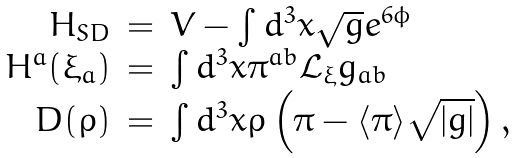Convert formula to latex. <formula><loc_0><loc_0><loc_500><loc_500>\begin{array} { r c l } H _ { S D } & = & V - \int d ^ { 3 } x \sqrt { g } e ^ { 6 \phi } \\ H ^ { a } ( \xi _ { a } ) & = & \int d ^ { 3 } x \pi ^ { a b } \mathcal { L } _ { \xi } g _ { a b } \\ D ( \rho ) & = & \int d ^ { 3 } x \rho \left ( \pi - \langle \pi \rangle \sqrt { | g | } \right ) , \end{array}</formula> 